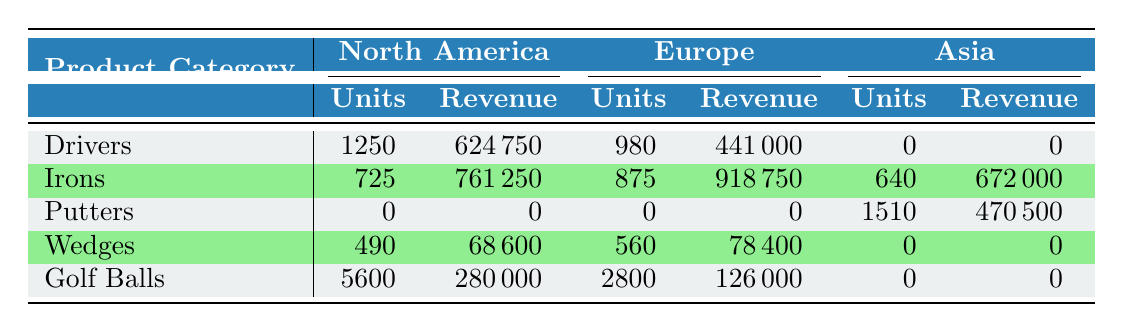What is the total number of units sold for Drivers in North America? In the table, we find that 1250 units of Drivers were sold in North America. There are no other entries for Drivers in this region, so this value is taken directly from the table.
Answer: 1250 Which product category had the highest revenue in Europe? To find the highest revenue in Europe, we compare the revenue figures for each product category: Drivers (441000), Irons (918750), Putters (0), Wedges (78400), Golf Balls (126000). The Irons category generated the highest revenue at 918750.
Answer: Irons What is the difference in units sold between Golf Balls in North America and Europe? From the table, Golf Balls sold 5600 units in North America and 2800 units in Europe. The difference is calculated as 5600 - 2800 = 2800 units.
Answer: 2800 Did Putters generate any revenue in North America? According to the table, under the Putters category, the revenue for North America is listed as 0. Therefore, it can be concluded that Putters did not generate any revenue in that region.
Answer: No What is the total revenue for all Wedges sold across all regions? The total revenue for Wedges can be derived by adding the revenue for each region: North America (68600), Europe (78400), and Asia (0). The total revenue is 68600 + 78400 + 0 = 147000.
Answer: 147000 Which product categories had sold units in Asia, and what were the total units sold for those categories? From the table, the only product categories with sold units in Asia are Irons (640 units) and Putters (620 units). Summing these gives a total of 640 + 620 = 1260 units sold in Asia.
Answer: 1260 What was the total revenue for Golf Balls in South America? The table shows that Golf Balls were not sold in South America (0 units sold and therefore 0 revenue). This is directly stated in the table, which implies no revenue was generated from Golf Balls in that region.
Answer: 0 What percentage of the total units sold in Europe belongs to Irons? The total units sold in Europe are from Drivers (980), Irons (875), Putters (0), Wedges (560), and Golf Balls (2800). Thus, total units = 980 + 875 + 0 + 560 + 2800 = 4215 units. The percentage of units for Irons is (875/4215) * 100 ≈ 20.73%.
Answer: 20.73% What is the total revenue for all product categories in South America? The table shows the revenue for the relevant product categories in South America: Putters (108500) and Golf Balls (0). Therefore, the total revenue is calculated as 108500 + 0 = 108500.
Answer: 108500 